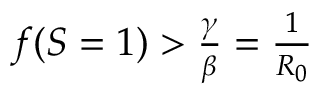Convert formula to latex. <formula><loc_0><loc_0><loc_500><loc_500>\begin{array} { r } { f ( S = 1 ) > \frac { \gamma } { \beta } = \frac { 1 } { R _ { 0 } } } \end{array}</formula> 